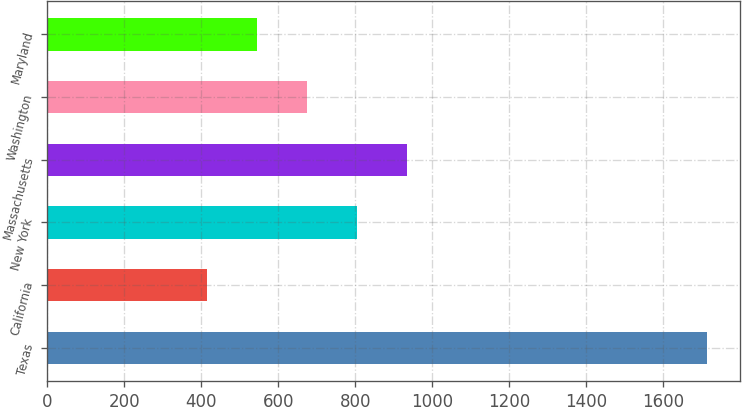Convert chart. <chart><loc_0><loc_0><loc_500><loc_500><bar_chart><fcel>Texas<fcel>California<fcel>New York<fcel>Massachusetts<fcel>Washington<fcel>Maryland<nl><fcel>1713<fcel>415<fcel>804.4<fcel>934.2<fcel>674.6<fcel>544.8<nl></chart> 